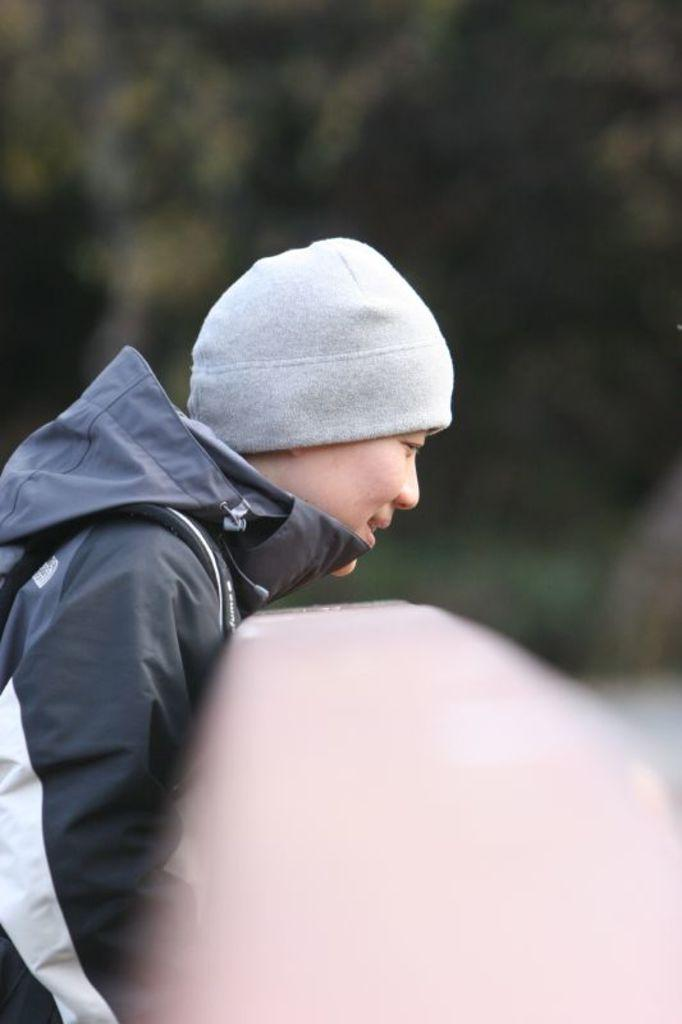What can be seen in the foreground of the image? There is a person in the image. What is the person holding in the image? The person is holding an object. Can you describe the background of the image? The background of the image is blurred. What sign is the person holding in the image? There is no sign present in the image; the person is holding an object. What type of trousers is the person wearing in the image? The provided facts do not mention the person's clothing, so we cannot determine the type of trousers they are wearing. 